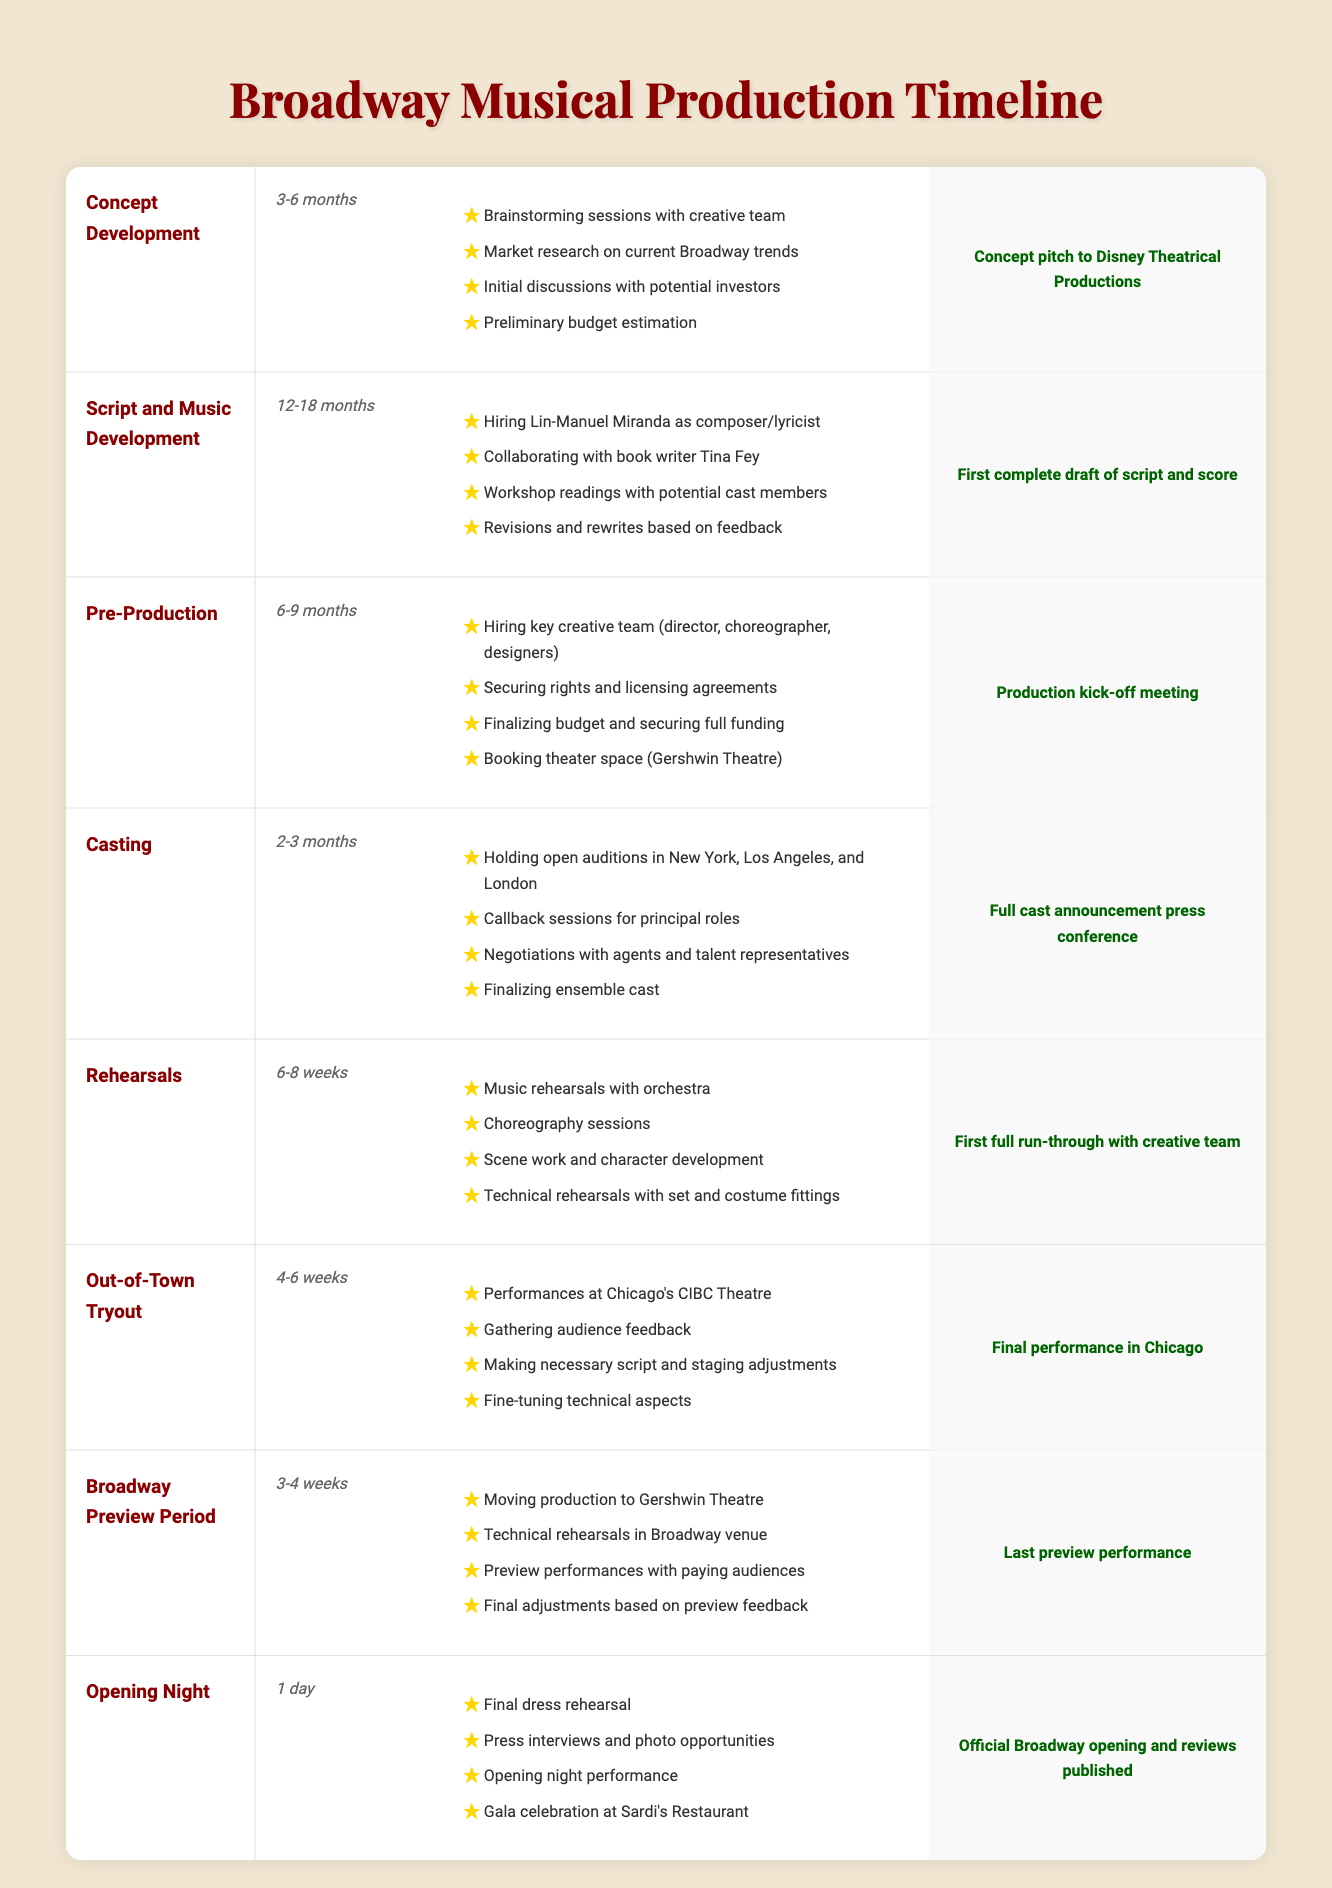What is the duration of the Script and Music Development stage? The duration for the Script and Music Development stage is listed in the table, specifically as "12-18 months".
Answer: 12-18 months Which stage involves hiring the key creative team? According to the table, the stage that involves hiring the key creative team (director, choreographer, designers) is Pre-Production.
Answer: Pre-Production Is the opening night just one day? The table specifies that the duration of the Opening Night stage is "1 day", confirming that it indeed takes place in a single day.
Answer: Yes What are the key activities during the Rehearsals stage? The table lists the key activities that occur during the Rehearsals stage: music rehearsals with orchestra, choreography sessions, scene work and character development, and technical rehearsals with set and costume fittings.
Answer: Music rehearsals with orchestra, choreography sessions, scene work and character development, technical rehearsals with set and costume fittings How many months do you need for Concept Development and Pre-Production combined? For Concept Development, the duration is 3-6 months, while Pre-Production is 6-9 months. If we take the minimum, this is 3 + 6 = 9 months, and the maximum would be 6 + 9 = 15 months. Thus, the combined duration is between 9 and 15 months.
Answer: 9-15 months What is the milestone for Out-of-Town Tryout? The table indicates that the milestone for the Out-of-Town Tryout stage is "Final performance in Chicago".
Answer: Final performance in Chicago Which stage has the longest duration in the timeline? The longest duration in the timeline is during the Script and Music Development stage, lasting 12-18 months. This can be verified by comparing the durations listed in the table.
Answer: Script and Music Development Are there any activities listed for the Broadway Preview Period? Yes, the table provides several key activities for the Broadway Preview Period, including moving production to Gershwin Theatre, technical rehearsals in the Broadway venue, preview performances with paying audiences, and final adjustments based on preview feedback.
Answer: Yes What is the final milestone after the Opening Night? The final milestone listed in the table after the Opening Night stage is "Official Broadway opening and reviews published".
Answer: Official Broadway opening and reviews published 